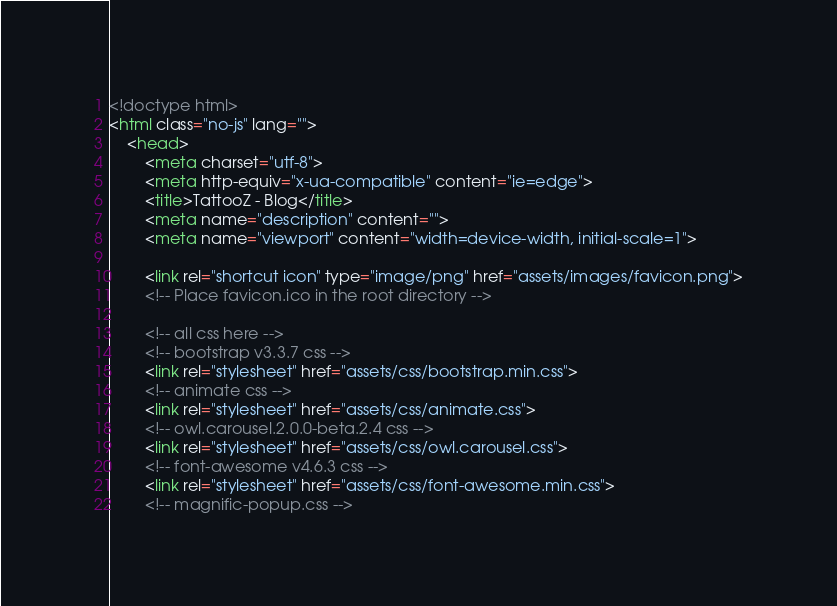Convert code to text. <code><loc_0><loc_0><loc_500><loc_500><_HTML_><!doctype html>
<html class="no-js" lang="">
    <head>
        <meta charset="utf-8">
        <meta http-equiv="x-ua-compatible" content="ie=edge">
        <title>TattooZ - Blog</title>
        <meta name="description" content="">
        <meta name="viewport" content="width=device-width, initial-scale=1">

        <link rel="shortcut icon" type="image/png" href="assets/images/favicon.png">
        <!-- Place favicon.ico in the root directory -->

        <!-- all css here -->
        <!-- bootstrap v3.3.7 css -->
        <link rel="stylesheet" href="assets/css/bootstrap.min.css">
        <!-- animate css -->
        <link rel="stylesheet" href="assets/css/animate.css">
        <!-- owl.carousel.2.0.0-beta.2.4 css -->
        <link rel="stylesheet" href="assets/css/owl.carousel.css">
        <!-- font-awesome v4.6.3 css -->
        <link rel="stylesheet" href="assets/css/font-awesome.min.css">
        <!-- magnific-popup.css --></code> 